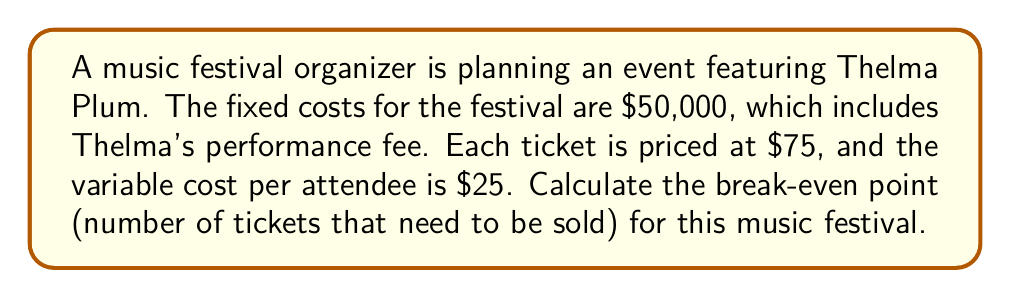Can you solve this math problem? To calculate the break-even point, we need to determine the number of tickets sold where total revenue equals total costs.

Let $x$ be the number of tickets sold.

1. Set up the equation:
   Total Revenue = Total Costs
   $75x = 50000 + 25x$

2. Simplify the equation:
   $75x = 50000 + 25x$
   $75x - 25x = 50000$
   $50x = 50000$

3. Solve for $x$:
   $$x = \frac{50000}{50} = 1000$$

Therefore, the festival needs to sell 1000 tickets to break even.

To verify:
Revenue: $75 \times 1000 = 75000$
Costs: $50000 + (25 \times 1000) = 75000$

Revenue equals costs, confirming the break-even point.
Answer: 1000 tickets 